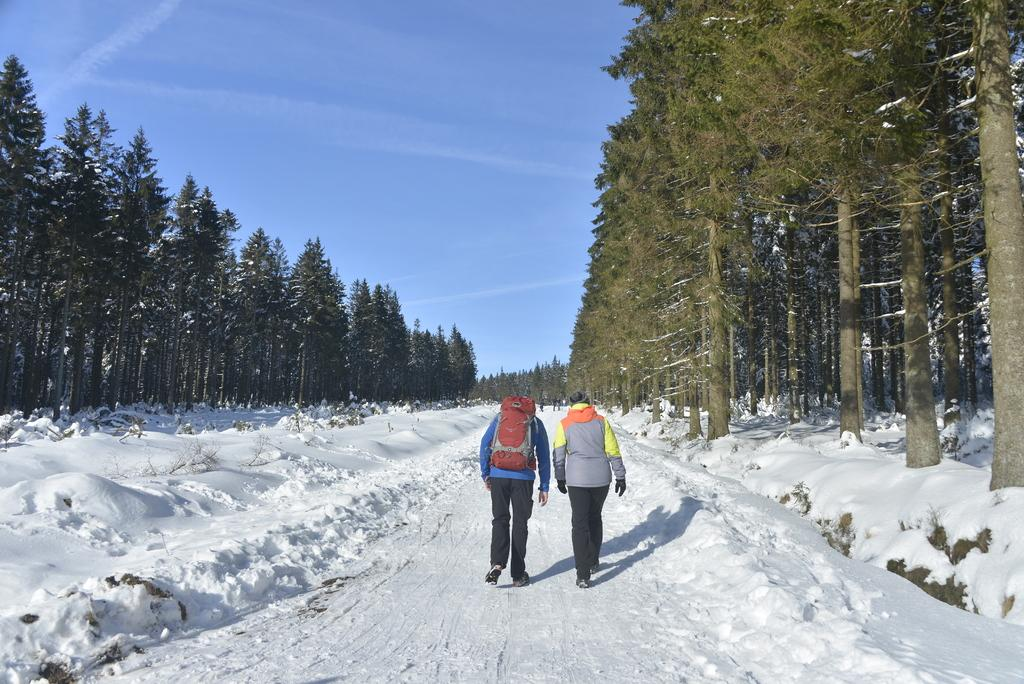How many people are in the image? There are two people in the image. What are the people doing in the image? The people are walking on the snow. What can be seen in the background of the image? There are trees and the sky visible in the background of the image. What type of sugar can be seen on the flesh of the people in the image? There is no sugar or flesh visible in the image; the people are walking on snow. What type of clouds can be seen in the image? The provided facts do not mention clouds, only the sky is visible in the background of the image. 